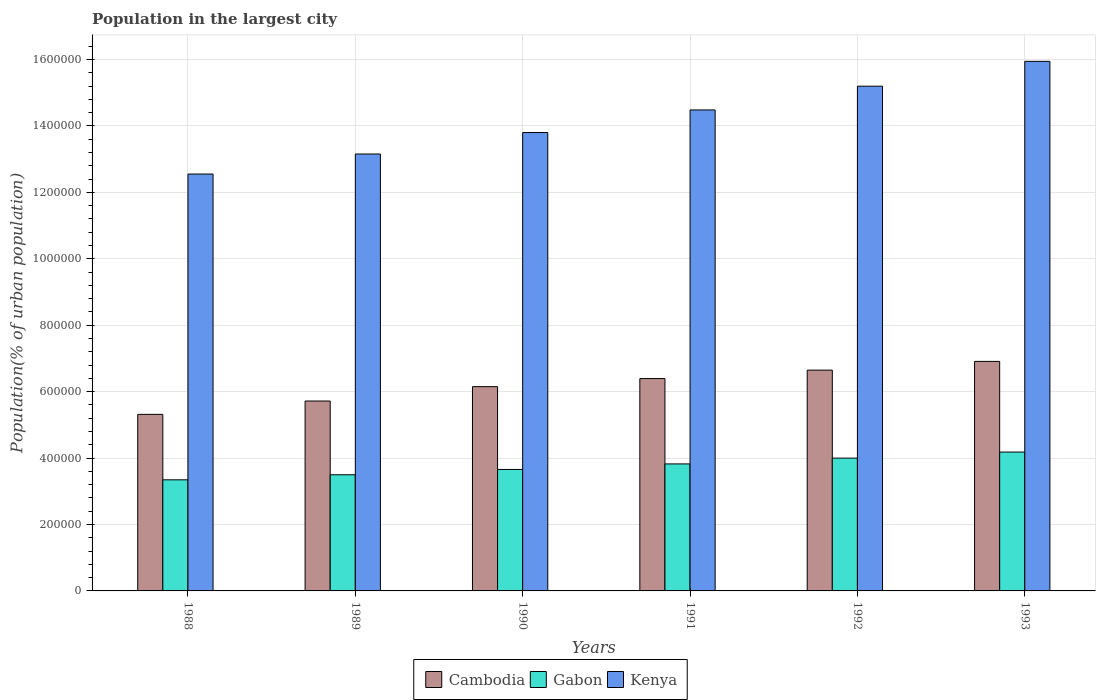How many different coloured bars are there?
Your answer should be compact. 3. How many groups of bars are there?
Provide a succinct answer. 6. Are the number of bars per tick equal to the number of legend labels?
Make the answer very short. Yes. Are the number of bars on each tick of the X-axis equal?
Provide a short and direct response. Yes. In how many cases, is the number of bars for a given year not equal to the number of legend labels?
Offer a terse response. 0. What is the population in the largest city in Cambodia in 1992?
Your answer should be compact. 6.65e+05. Across all years, what is the maximum population in the largest city in Kenya?
Ensure brevity in your answer.  1.59e+06. Across all years, what is the minimum population in the largest city in Kenya?
Make the answer very short. 1.26e+06. In which year was the population in the largest city in Cambodia maximum?
Your answer should be compact. 1993. In which year was the population in the largest city in Cambodia minimum?
Provide a succinct answer. 1988. What is the total population in the largest city in Gabon in the graph?
Offer a terse response. 2.25e+06. What is the difference between the population in the largest city in Kenya in 1988 and that in 1991?
Your response must be concise. -1.93e+05. What is the difference between the population in the largest city in Gabon in 1988 and the population in the largest city in Kenya in 1989?
Provide a short and direct response. -9.81e+05. What is the average population in the largest city in Cambodia per year?
Your answer should be very brief. 6.19e+05. In the year 1991, what is the difference between the population in the largest city in Kenya and population in the largest city in Gabon?
Your answer should be compact. 1.07e+06. In how many years, is the population in the largest city in Gabon greater than 320000 %?
Keep it short and to the point. 6. What is the ratio of the population in the largest city in Cambodia in 1992 to that in 1993?
Provide a succinct answer. 0.96. Is the population in the largest city in Cambodia in 1988 less than that in 1992?
Provide a succinct answer. Yes. What is the difference between the highest and the second highest population in the largest city in Cambodia?
Your answer should be very brief. 2.63e+04. What is the difference between the highest and the lowest population in the largest city in Cambodia?
Your response must be concise. 1.59e+05. In how many years, is the population in the largest city in Kenya greater than the average population in the largest city in Kenya taken over all years?
Your answer should be compact. 3. What does the 2nd bar from the left in 1990 represents?
Provide a short and direct response. Gabon. What does the 2nd bar from the right in 1992 represents?
Ensure brevity in your answer.  Gabon. How many bars are there?
Keep it short and to the point. 18. Are all the bars in the graph horizontal?
Your response must be concise. No. How many years are there in the graph?
Your answer should be very brief. 6. What is the difference between two consecutive major ticks on the Y-axis?
Offer a very short reply. 2.00e+05. Does the graph contain any zero values?
Offer a terse response. No. Does the graph contain grids?
Your answer should be very brief. Yes. Where does the legend appear in the graph?
Give a very brief answer. Bottom center. How many legend labels are there?
Give a very brief answer. 3. How are the legend labels stacked?
Provide a succinct answer. Horizontal. What is the title of the graph?
Offer a terse response. Population in the largest city. Does "Sint Maarten (Dutch part)" appear as one of the legend labels in the graph?
Keep it short and to the point. No. What is the label or title of the Y-axis?
Your answer should be very brief. Population(% of urban population). What is the Population(% of urban population) of Cambodia in 1988?
Provide a short and direct response. 5.32e+05. What is the Population(% of urban population) in Gabon in 1988?
Make the answer very short. 3.35e+05. What is the Population(% of urban population) of Kenya in 1988?
Provide a short and direct response. 1.26e+06. What is the Population(% of urban population) in Cambodia in 1989?
Your answer should be very brief. 5.72e+05. What is the Population(% of urban population) in Gabon in 1989?
Keep it short and to the point. 3.50e+05. What is the Population(% of urban population) of Kenya in 1989?
Your response must be concise. 1.32e+06. What is the Population(% of urban population) of Cambodia in 1990?
Give a very brief answer. 6.15e+05. What is the Population(% of urban population) of Gabon in 1990?
Ensure brevity in your answer.  3.66e+05. What is the Population(% of urban population) of Kenya in 1990?
Your answer should be very brief. 1.38e+06. What is the Population(% of urban population) of Cambodia in 1991?
Make the answer very short. 6.39e+05. What is the Population(% of urban population) in Gabon in 1991?
Offer a terse response. 3.82e+05. What is the Population(% of urban population) in Kenya in 1991?
Your answer should be very brief. 1.45e+06. What is the Population(% of urban population) in Cambodia in 1992?
Provide a short and direct response. 6.65e+05. What is the Population(% of urban population) of Gabon in 1992?
Ensure brevity in your answer.  4.00e+05. What is the Population(% of urban population) in Kenya in 1992?
Your answer should be compact. 1.52e+06. What is the Population(% of urban population) of Cambodia in 1993?
Your answer should be very brief. 6.91e+05. What is the Population(% of urban population) in Gabon in 1993?
Give a very brief answer. 4.18e+05. What is the Population(% of urban population) in Kenya in 1993?
Your answer should be compact. 1.59e+06. Across all years, what is the maximum Population(% of urban population) of Cambodia?
Make the answer very short. 6.91e+05. Across all years, what is the maximum Population(% of urban population) of Gabon?
Your answer should be compact. 4.18e+05. Across all years, what is the maximum Population(% of urban population) of Kenya?
Your response must be concise. 1.59e+06. Across all years, what is the minimum Population(% of urban population) in Cambodia?
Make the answer very short. 5.32e+05. Across all years, what is the minimum Population(% of urban population) of Gabon?
Give a very brief answer. 3.35e+05. Across all years, what is the minimum Population(% of urban population) of Kenya?
Your response must be concise. 1.26e+06. What is the total Population(% of urban population) in Cambodia in the graph?
Provide a short and direct response. 3.71e+06. What is the total Population(% of urban population) of Gabon in the graph?
Make the answer very short. 2.25e+06. What is the total Population(% of urban population) of Kenya in the graph?
Your answer should be compact. 8.51e+06. What is the difference between the Population(% of urban population) of Cambodia in 1988 and that in 1989?
Ensure brevity in your answer.  -4.02e+04. What is the difference between the Population(% of urban population) of Gabon in 1988 and that in 1989?
Your response must be concise. -1.52e+04. What is the difference between the Population(% of urban population) of Kenya in 1988 and that in 1989?
Offer a terse response. -6.03e+04. What is the difference between the Population(% of urban population) of Cambodia in 1988 and that in 1990?
Your response must be concise. -8.35e+04. What is the difference between the Population(% of urban population) in Gabon in 1988 and that in 1990?
Your response must be concise. -3.12e+04. What is the difference between the Population(% of urban population) in Kenya in 1988 and that in 1990?
Offer a terse response. -1.25e+05. What is the difference between the Population(% of urban population) of Cambodia in 1988 and that in 1991?
Your answer should be compact. -1.08e+05. What is the difference between the Population(% of urban population) in Gabon in 1988 and that in 1991?
Ensure brevity in your answer.  -4.79e+04. What is the difference between the Population(% of urban population) of Kenya in 1988 and that in 1991?
Make the answer very short. -1.93e+05. What is the difference between the Population(% of urban population) of Cambodia in 1988 and that in 1992?
Make the answer very short. -1.33e+05. What is the difference between the Population(% of urban population) in Gabon in 1988 and that in 1992?
Your answer should be very brief. -6.53e+04. What is the difference between the Population(% of urban population) in Kenya in 1988 and that in 1992?
Your answer should be very brief. -2.64e+05. What is the difference between the Population(% of urban population) in Cambodia in 1988 and that in 1993?
Keep it short and to the point. -1.59e+05. What is the difference between the Population(% of urban population) of Gabon in 1988 and that in 1993?
Your answer should be very brief. -8.36e+04. What is the difference between the Population(% of urban population) in Kenya in 1988 and that in 1993?
Your answer should be very brief. -3.39e+05. What is the difference between the Population(% of urban population) in Cambodia in 1989 and that in 1990?
Offer a very short reply. -4.33e+04. What is the difference between the Population(% of urban population) of Gabon in 1989 and that in 1990?
Offer a terse response. -1.60e+04. What is the difference between the Population(% of urban population) in Kenya in 1989 and that in 1990?
Provide a succinct answer. -6.46e+04. What is the difference between the Population(% of urban population) of Cambodia in 1989 and that in 1991?
Give a very brief answer. -6.76e+04. What is the difference between the Population(% of urban population) in Gabon in 1989 and that in 1991?
Ensure brevity in your answer.  -3.26e+04. What is the difference between the Population(% of urban population) of Kenya in 1989 and that in 1991?
Provide a short and direct response. -1.33e+05. What is the difference between the Population(% of urban population) in Cambodia in 1989 and that in 1992?
Your response must be concise. -9.30e+04. What is the difference between the Population(% of urban population) of Gabon in 1989 and that in 1992?
Offer a terse response. -5.01e+04. What is the difference between the Population(% of urban population) in Kenya in 1989 and that in 1992?
Give a very brief answer. -2.04e+05. What is the difference between the Population(% of urban population) in Cambodia in 1989 and that in 1993?
Provide a short and direct response. -1.19e+05. What is the difference between the Population(% of urban population) of Gabon in 1989 and that in 1993?
Your answer should be compact. -6.83e+04. What is the difference between the Population(% of urban population) in Kenya in 1989 and that in 1993?
Ensure brevity in your answer.  -2.79e+05. What is the difference between the Population(% of urban population) of Cambodia in 1990 and that in 1991?
Your response must be concise. -2.44e+04. What is the difference between the Population(% of urban population) in Gabon in 1990 and that in 1991?
Provide a short and direct response. -1.67e+04. What is the difference between the Population(% of urban population) of Kenya in 1990 and that in 1991?
Keep it short and to the point. -6.80e+04. What is the difference between the Population(% of urban population) in Cambodia in 1990 and that in 1992?
Ensure brevity in your answer.  -4.97e+04. What is the difference between the Population(% of urban population) of Gabon in 1990 and that in 1992?
Keep it short and to the point. -3.42e+04. What is the difference between the Population(% of urban population) of Kenya in 1990 and that in 1992?
Offer a very short reply. -1.40e+05. What is the difference between the Population(% of urban population) in Cambodia in 1990 and that in 1993?
Make the answer very short. -7.60e+04. What is the difference between the Population(% of urban population) of Gabon in 1990 and that in 1993?
Provide a short and direct response. -5.24e+04. What is the difference between the Population(% of urban population) of Kenya in 1990 and that in 1993?
Offer a terse response. -2.14e+05. What is the difference between the Population(% of urban population) in Cambodia in 1991 and that in 1992?
Offer a terse response. -2.54e+04. What is the difference between the Population(% of urban population) in Gabon in 1991 and that in 1992?
Offer a terse response. -1.75e+04. What is the difference between the Population(% of urban population) in Kenya in 1991 and that in 1992?
Your answer should be very brief. -7.15e+04. What is the difference between the Population(% of urban population) of Cambodia in 1991 and that in 1993?
Provide a succinct answer. -5.16e+04. What is the difference between the Population(% of urban population) in Gabon in 1991 and that in 1993?
Your answer should be very brief. -3.57e+04. What is the difference between the Population(% of urban population) in Kenya in 1991 and that in 1993?
Offer a very short reply. -1.46e+05. What is the difference between the Population(% of urban population) of Cambodia in 1992 and that in 1993?
Give a very brief answer. -2.63e+04. What is the difference between the Population(% of urban population) in Gabon in 1992 and that in 1993?
Provide a short and direct response. -1.82e+04. What is the difference between the Population(% of urban population) in Kenya in 1992 and that in 1993?
Make the answer very short. -7.48e+04. What is the difference between the Population(% of urban population) in Cambodia in 1988 and the Population(% of urban population) in Gabon in 1989?
Provide a succinct answer. 1.82e+05. What is the difference between the Population(% of urban population) in Cambodia in 1988 and the Population(% of urban population) in Kenya in 1989?
Your answer should be very brief. -7.84e+05. What is the difference between the Population(% of urban population) in Gabon in 1988 and the Population(% of urban population) in Kenya in 1989?
Provide a short and direct response. -9.81e+05. What is the difference between the Population(% of urban population) in Cambodia in 1988 and the Population(% of urban population) in Gabon in 1990?
Offer a terse response. 1.66e+05. What is the difference between the Population(% of urban population) of Cambodia in 1988 and the Population(% of urban population) of Kenya in 1990?
Offer a terse response. -8.48e+05. What is the difference between the Population(% of urban population) in Gabon in 1988 and the Population(% of urban population) in Kenya in 1990?
Provide a succinct answer. -1.05e+06. What is the difference between the Population(% of urban population) in Cambodia in 1988 and the Population(% of urban population) in Gabon in 1991?
Offer a very short reply. 1.49e+05. What is the difference between the Population(% of urban population) of Cambodia in 1988 and the Population(% of urban population) of Kenya in 1991?
Provide a succinct answer. -9.17e+05. What is the difference between the Population(% of urban population) of Gabon in 1988 and the Population(% of urban population) of Kenya in 1991?
Ensure brevity in your answer.  -1.11e+06. What is the difference between the Population(% of urban population) of Cambodia in 1988 and the Population(% of urban population) of Gabon in 1992?
Provide a succinct answer. 1.32e+05. What is the difference between the Population(% of urban population) in Cambodia in 1988 and the Population(% of urban population) in Kenya in 1992?
Make the answer very short. -9.88e+05. What is the difference between the Population(% of urban population) of Gabon in 1988 and the Population(% of urban population) of Kenya in 1992?
Offer a very short reply. -1.19e+06. What is the difference between the Population(% of urban population) of Cambodia in 1988 and the Population(% of urban population) of Gabon in 1993?
Your answer should be very brief. 1.13e+05. What is the difference between the Population(% of urban population) in Cambodia in 1988 and the Population(% of urban population) in Kenya in 1993?
Make the answer very short. -1.06e+06. What is the difference between the Population(% of urban population) in Gabon in 1988 and the Population(% of urban population) in Kenya in 1993?
Your response must be concise. -1.26e+06. What is the difference between the Population(% of urban population) of Cambodia in 1989 and the Population(% of urban population) of Gabon in 1990?
Offer a terse response. 2.06e+05. What is the difference between the Population(% of urban population) of Cambodia in 1989 and the Population(% of urban population) of Kenya in 1990?
Make the answer very short. -8.08e+05. What is the difference between the Population(% of urban population) in Gabon in 1989 and the Population(% of urban population) in Kenya in 1990?
Keep it short and to the point. -1.03e+06. What is the difference between the Population(% of urban population) in Cambodia in 1989 and the Population(% of urban population) in Gabon in 1991?
Keep it short and to the point. 1.89e+05. What is the difference between the Population(% of urban population) of Cambodia in 1989 and the Population(% of urban population) of Kenya in 1991?
Offer a very short reply. -8.76e+05. What is the difference between the Population(% of urban population) of Gabon in 1989 and the Population(% of urban population) of Kenya in 1991?
Give a very brief answer. -1.10e+06. What is the difference between the Population(% of urban population) in Cambodia in 1989 and the Population(% of urban population) in Gabon in 1992?
Make the answer very short. 1.72e+05. What is the difference between the Population(% of urban population) in Cambodia in 1989 and the Population(% of urban population) in Kenya in 1992?
Keep it short and to the point. -9.48e+05. What is the difference between the Population(% of urban population) of Gabon in 1989 and the Population(% of urban population) of Kenya in 1992?
Provide a succinct answer. -1.17e+06. What is the difference between the Population(% of urban population) in Cambodia in 1989 and the Population(% of urban population) in Gabon in 1993?
Offer a terse response. 1.54e+05. What is the difference between the Population(% of urban population) of Cambodia in 1989 and the Population(% of urban population) of Kenya in 1993?
Your answer should be very brief. -1.02e+06. What is the difference between the Population(% of urban population) of Gabon in 1989 and the Population(% of urban population) of Kenya in 1993?
Give a very brief answer. -1.24e+06. What is the difference between the Population(% of urban population) in Cambodia in 1990 and the Population(% of urban population) in Gabon in 1991?
Make the answer very short. 2.33e+05. What is the difference between the Population(% of urban population) of Cambodia in 1990 and the Population(% of urban population) of Kenya in 1991?
Provide a succinct answer. -8.33e+05. What is the difference between the Population(% of urban population) in Gabon in 1990 and the Population(% of urban population) in Kenya in 1991?
Provide a succinct answer. -1.08e+06. What is the difference between the Population(% of urban population) in Cambodia in 1990 and the Population(% of urban population) in Gabon in 1992?
Give a very brief answer. 2.15e+05. What is the difference between the Population(% of urban population) of Cambodia in 1990 and the Population(% of urban population) of Kenya in 1992?
Your response must be concise. -9.05e+05. What is the difference between the Population(% of urban population) in Gabon in 1990 and the Population(% of urban population) in Kenya in 1992?
Your response must be concise. -1.15e+06. What is the difference between the Population(% of urban population) of Cambodia in 1990 and the Population(% of urban population) of Gabon in 1993?
Keep it short and to the point. 1.97e+05. What is the difference between the Population(% of urban population) of Cambodia in 1990 and the Population(% of urban population) of Kenya in 1993?
Provide a succinct answer. -9.79e+05. What is the difference between the Population(% of urban population) of Gabon in 1990 and the Population(% of urban population) of Kenya in 1993?
Give a very brief answer. -1.23e+06. What is the difference between the Population(% of urban population) of Cambodia in 1991 and the Population(% of urban population) of Gabon in 1992?
Provide a short and direct response. 2.40e+05. What is the difference between the Population(% of urban population) in Cambodia in 1991 and the Population(% of urban population) in Kenya in 1992?
Your response must be concise. -8.80e+05. What is the difference between the Population(% of urban population) of Gabon in 1991 and the Population(% of urban population) of Kenya in 1992?
Your answer should be very brief. -1.14e+06. What is the difference between the Population(% of urban population) of Cambodia in 1991 and the Population(% of urban population) of Gabon in 1993?
Offer a terse response. 2.21e+05. What is the difference between the Population(% of urban population) in Cambodia in 1991 and the Population(% of urban population) in Kenya in 1993?
Your answer should be compact. -9.55e+05. What is the difference between the Population(% of urban population) of Gabon in 1991 and the Population(% of urban population) of Kenya in 1993?
Keep it short and to the point. -1.21e+06. What is the difference between the Population(% of urban population) in Cambodia in 1992 and the Population(% of urban population) in Gabon in 1993?
Provide a short and direct response. 2.47e+05. What is the difference between the Population(% of urban population) in Cambodia in 1992 and the Population(% of urban population) in Kenya in 1993?
Offer a very short reply. -9.30e+05. What is the difference between the Population(% of urban population) of Gabon in 1992 and the Population(% of urban population) of Kenya in 1993?
Ensure brevity in your answer.  -1.19e+06. What is the average Population(% of urban population) of Cambodia per year?
Your answer should be compact. 6.19e+05. What is the average Population(% of urban population) in Gabon per year?
Ensure brevity in your answer.  3.75e+05. What is the average Population(% of urban population) in Kenya per year?
Make the answer very short. 1.42e+06. In the year 1988, what is the difference between the Population(% of urban population) in Cambodia and Population(% of urban population) in Gabon?
Keep it short and to the point. 1.97e+05. In the year 1988, what is the difference between the Population(% of urban population) of Cambodia and Population(% of urban population) of Kenya?
Offer a terse response. -7.24e+05. In the year 1988, what is the difference between the Population(% of urban population) of Gabon and Population(% of urban population) of Kenya?
Your answer should be compact. -9.21e+05. In the year 1989, what is the difference between the Population(% of urban population) in Cambodia and Population(% of urban population) in Gabon?
Offer a terse response. 2.22e+05. In the year 1989, what is the difference between the Population(% of urban population) of Cambodia and Population(% of urban population) of Kenya?
Ensure brevity in your answer.  -7.44e+05. In the year 1989, what is the difference between the Population(% of urban population) in Gabon and Population(% of urban population) in Kenya?
Your response must be concise. -9.66e+05. In the year 1990, what is the difference between the Population(% of urban population) of Cambodia and Population(% of urban population) of Gabon?
Provide a succinct answer. 2.49e+05. In the year 1990, what is the difference between the Population(% of urban population) in Cambodia and Population(% of urban population) in Kenya?
Give a very brief answer. -7.65e+05. In the year 1990, what is the difference between the Population(% of urban population) in Gabon and Population(% of urban population) in Kenya?
Provide a short and direct response. -1.01e+06. In the year 1991, what is the difference between the Population(% of urban population) in Cambodia and Population(% of urban population) in Gabon?
Offer a terse response. 2.57e+05. In the year 1991, what is the difference between the Population(% of urban population) of Cambodia and Population(% of urban population) of Kenya?
Give a very brief answer. -8.09e+05. In the year 1991, what is the difference between the Population(% of urban population) in Gabon and Population(% of urban population) in Kenya?
Ensure brevity in your answer.  -1.07e+06. In the year 1992, what is the difference between the Population(% of urban population) of Cambodia and Population(% of urban population) of Gabon?
Your response must be concise. 2.65e+05. In the year 1992, what is the difference between the Population(% of urban population) in Cambodia and Population(% of urban population) in Kenya?
Provide a succinct answer. -8.55e+05. In the year 1992, what is the difference between the Population(% of urban population) in Gabon and Population(% of urban population) in Kenya?
Give a very brief answer. -1.12e+06. In the year 1993, what is the difference between the Population(% of urban population) of Cambodia and Population(% of urban population) of Gabon?
Your answer should be compact. 2.73e+05. In the year 1993, what is the difference between the Population(% of urban population) of Cambodia and Population(% of urban population) of Kenya?
Provide a succinct answer. -9.03e+05. In the year 1993, what is the difference between the Population(% of urban population) of Gabon and Population(% of urban population) of Kenya?
Your response must be concise. -1.18e+06. What is the ratio of the Population(% of urban population) of Cambodia in 1988 to that in 1989?
Ensure brevity in your answer.  0.93. What is the ratio of the Population(% of urban population) of Gabon in 1988 to that in 1989?
Offer a terse response. 0.96. What is the ratio of the Population(% of urban population) of Kenya in 1988 to that in 1989?
Give a very brief answer. 0.95. What is the ratio of the Population(% of urban population) of Cambodia in 1988 to that in 1990?
Offer a terse response. 0.86. What is the ratio of the Population(% of urban population) of Gabon in 1988 to that in 1990?
Your answer should be compact. 0.91. What is the ratio of the Population(% of urban population) in Kenya in 1988 to that in 1990?
Give a very brief answer. 0.91. What is the ratio of the Population(% of urban population) in Cambodia in 1988 to that in 1991?
Offer a terse response. 0.83. What is the ratio of the Population(% of urban population) of Gabon in 1988 to that in 1991?
Offer a very short reply. 0.87. What is the ratio of the Population(% of urban population) in Kenya in 1988 to that in 1991?
Your answer should be compact. 0.87. What is the ratio of the Population(% of urban population) of Cambodia in 1988 to that in 1992?
Your response must be concise. 0.8. What is the ratio of the Population(% of urban population) of Gabon in 1988 to that in 1992?
Make the answer very short. 0.84. What is the ratio of the Population(% of urban population) of Kenya in 1988 to that in 1992?
Give a very brief answer. 0.83. What is the ratio of the Population(% of urban population) in Cambodia in 1988 to that in 1993?
Offer a terse response. 0.77. What is the ratio of the Population(% of urban population) of Gabon in 1988 to that in 1993?
Offer a very short reply. 0.8. What is the ratio of the Population(% of urban population) in Kenya in 1988 to that in 1993?
Give a very brief answer. 0.79. What is the ratio of the Population(% of urban population) in Cambodia in 1989 to that in 1990?
Your answer should be very brief. 0.93. What is the ratio of the Population(% of urban population) in Gabon in 1989 to that in 1990?
Provide a succinct answer. 0.96. What is the ratio of the Population(% of urban population) in Kenya in 1989 to that in 1990?
Provide a succinct answer. 0.95. What is the ratio of the Population(% of urban population) of Cambodia in 1989 to that in 1991?
Provide a short and direct response. 0.89. What is the ratio of the Population(% of urban population) in Gabon in 1989 to that in 1991?
Provide a succinct answer. 0.91. What is the ratio of the Population(% of urban population) in Kenya in 1989 to that in 1991?
Provide a succinct answer. 0.91. What is the ratio of the Population(% of urban population) in Cambodia in 1989 to that in 1992?
Give a very brief answer. 0.86. What is the ratio of the Population(% of urban population) of Gabon in 1989 to that in 1992?
Offer a terse response. 0.87. What is the ratio of the Population(% of urban population) of Kenya in 1989 to that in 1992?
Keep it short and to the point. 0.87. What is the ratio of the Population(% of urban population) in Cambodia in 1989 to that in 1993?
Keep it short and to the point. 0.83. What is the ratio of the Population(% of urban population) of Gabon in 1989 to that in 1993?
Offer a terse response. 0.84. What is the ratio of the Population(% of urban population) in Kenya in 1989 to that in 1993?
Provide a short and direct response. 0.82. What is the ratio of the Population(% of urban population) of Cambodia in 1990 to that in 1991?
Your answer should be very brief. 0.96. What is the ratio of the Population(% of urban population) in Gabon in 1990 to that in 1991?
Your response must be concise. 0.96. What is the ratio of the Population(% of urban population) in Kenya in 1990 to that in 1991?
Keep it short and to the point. 0.95. What is the ratio of the Population(% of urban population) of Cambodia in 1990 to that in 1992?
Offer a terse response. 0.93. What is the ratio of the Population(% of urban population) in Gabon in 1990 to that in 1992?
Your response must be concise. 0.91. What is the ratio of the Population(% of urban population) of Kenya in 1990 to that in 1992?
Provide a succinct answer. 0.91. What is the ratio of the Population(% of urban population) of Cambodia in 1990 to that in 1993?
Your response must be concise. 0.89. What is the ratio of the Population(% of urban population) of Gabon in 1990 to that in 1993?
Your answer should be very brief. 0.87. What is the ratio of the Population(% of urban population) of Kenya in 1990 to that in 1993?
Your answer should be very brief. 0.87. What is the ratio of the Population(% of urban population) of Cambodia in 1991 to that in 1992?
Ensure brevity in your answer.  0.96. What is the ratio of the Population(% of urban population) in Gabon in 1991 to that in 1992?
Offer a terse response. 0.96. What is the ratio of the Population(% of urban population) of Kenya in 1991 to that in 1992?
Keep it short and to the point. 0.95. What is the ratio of the Population(% of urban population) of Cambodia in 1991 to that in 1993?
Your answer should be compact. 0.93. What is the ratio of the Population(% of urban population) of Gabon in 1991 to that in 1993?
Provide a short and direct response. 0.91. What is the ratio of the Population(% of urban population) in Kenya in 1991 to that in 1993?
Keep it short and to the point. 0.91. What is the ratio of the Population(% of urban population) of Gabon in 1992 to that in 1993?
Your answer should be very brief. 0.96. What is the ratio of the Population(% of urban population) in Kenya in 1992 to that in 1993?
Keep it short and to the point. 0.95. What is the difference between the highest and the second highest Population(% of urban population) in Cambodia?
Your response must be concise. 2.63e+04. What is the difference between the highest and the second highest Population(% of urban population) of Gabon?
Keep it short and to the point. 1.82e+04. What is the difference between the highest and the second highest Population(% of urban population) in Kenya?
Offer a terse response. 7.48e+04. What is the difference between the highest and the lowest Population(% of urban population) in Cambodia?
Provide a short and direct response. 1.59e+05. What is the difference between the highest and the lowest Population(% of urban population) in Gabon?
Provide a short and direct response. 8.36e+04. What is the difference between the highest and the lowest Population(% of urban population) in Kenya?
Offer a very short reply. 3.39e+05. 